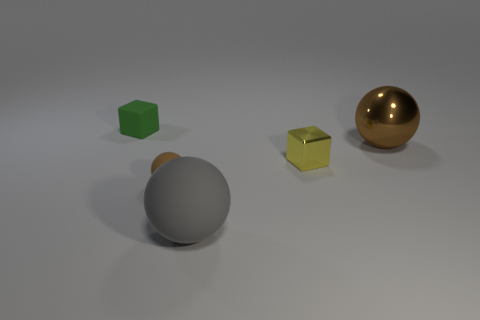There is a rubber ball right of the brown sphere in front of the yellow block; is there a small green rubber cube that is right of it?
Ensure brevity in your answer.  No. There is a large gray thing that is the same material as the green thing; what shape is it?
Keep it short and to the point. Sphere. Are there any other things that are the same shape as the green rubber thing?
Offer a very short reply. Yes. There is a yellow metallic object; what shape is it?
Ensure brevity in your answer.  Cube. There is a brown object that is right of the tiny matte ball; is its shape the same as the tiny brown thing?
Keep it short and to the point. Yes. Is the number of green objects on the left side of the large shiny sphere greater than the number of yellow objects that are in front of the yellow metallic object?
Offer a very short reply. Yes. What number of other things are there of the same size as the gray object?
Make the answer very short. 1. Is the shape of the tiny brown rubber object the same as the matte thing that is on the right side of the small brown matte ball?
Ensure brevity in your answer.  Yes. What number of matte objects are spheres or tiny cubes?
Keep it short and to the point. 3. Are there any other cubes that have the same color as the tiny matte cube?
Offer a very short reply. No. 